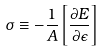<formula> <loc_0><loc_0><loc_500><loc_500>\sigma \equiv - \frac { 1 } { A } \left [ \frac { \partial E } { \partial \epsilon } \right ]</formula> 